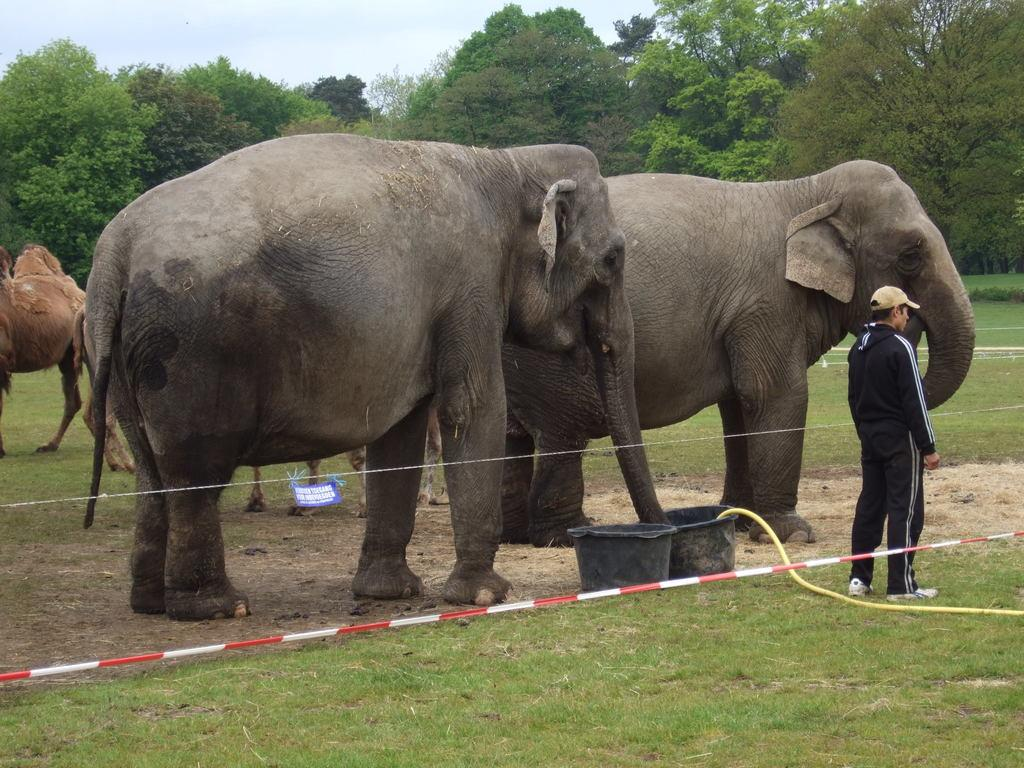What type of animals can be seen on the ground in the image? There are animals on the ground in the image, but their specific type is not mentioned in the facts. What can be seen in the background of the image? The sky is visible in the background of the image. What is present on the ground in addition to the animals? There are trees and grass in the image. What man-made objects can be seen in the image? There are tubs and a pipe in the image. How many babies are playing volleyball in the image? There are no babies or volleyballs present in the image. What effect does the pipe have on the animals in the image? The facts provided do not mention any effect the pipe has on the animals, so we cannot answer this question. 